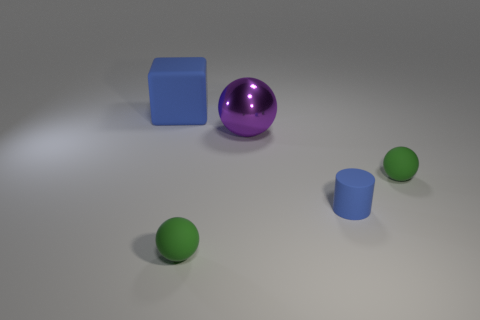What size is the purple sphere?
Your response must be concise. Large. What number of things are either large shiny spheres or rubber things that are in front of the big blue object?
Provide a succinct answer. 4. How many other things are there of the same color as the matte cube?
Offer a terse response. 1. Is the size of the shiny thing the same as the blue thing right of the blue cube?
Ensure brevity in your answer.  No. Is the size of the green thing that is on the left side of the metallic ball the same as the cylinder?
Offer a terse response. Yes. What number of other objects are there of the same material as the purple ball?
Offer a terse response. 0. Are there the same number of tiny blue cylinders that are on the right side of the tiny blue cylinder and green things that are left of the blue block?
Offer a terse response. Yes. What is the color of the large object that is right of the blue object that is behind the small green matte object that is on the right side of the metal thing?
Ensure brevity in your answer.  Purple. The large thing that is in front of the large blue cube has what shape?
Provide a succinct answer. Sphere. What is the shape of the large thing that is the same material as the tiny blue thing?
Provide a short and direct response. Cube. 